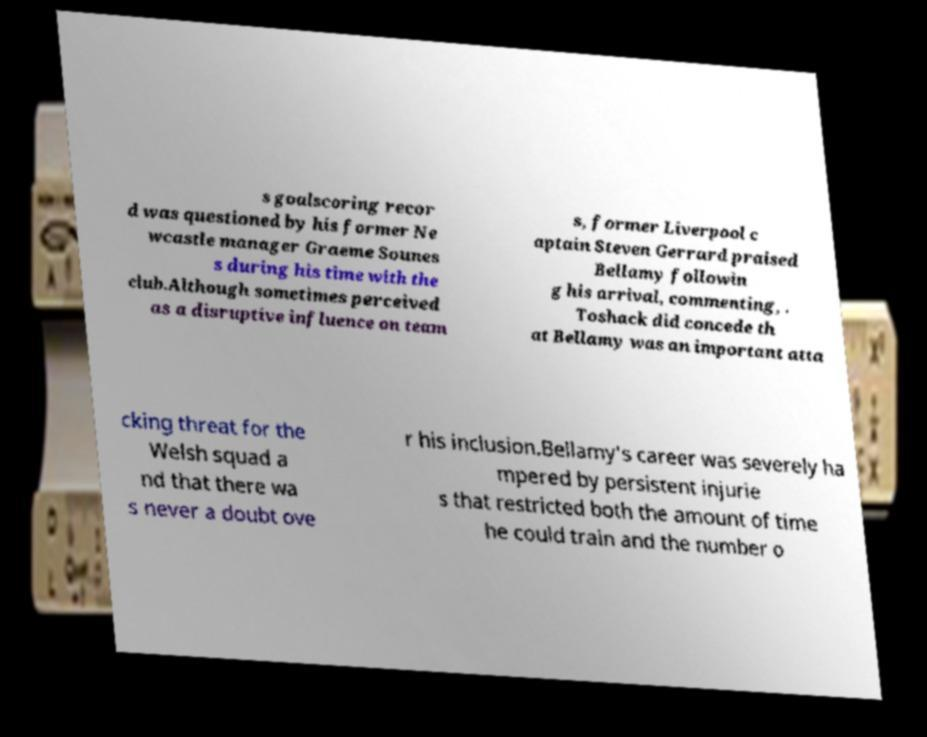Could you assist in decoding the text presented in this image and type it out clearly? s goalscoring recor d was questioned by his former Ne wcastle manager Graeme Sounes s during his time with the club.Although sometimes perceived as a disruptive influence on team s, former Liverpool c aptain Steven Gerrard praised Bellamy followin g his arrival, commenting, . Toshack did concede th at Bellamy was an important atta cking threat for the Welsh squad a nd that there wa s never a doubt ove r his inclusion.Bellamy's career was severely ha mpered by persistent injurie s that restricted both the amount of time he could train and the number o 